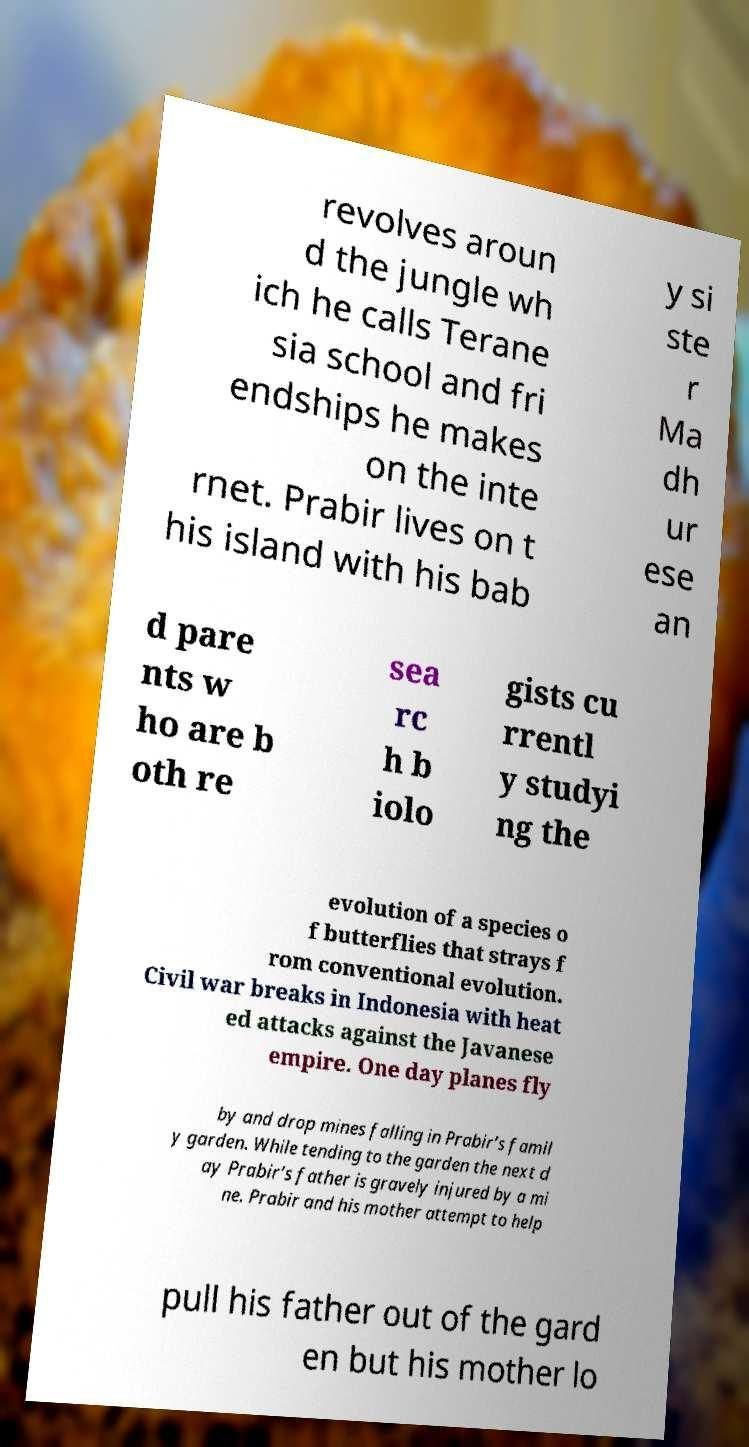For documentation purposes, I need the text within this image transcribed. Could you provide that? revolves aroun d the jungle wh ich he calls Terane sia school and fri endships he makes on the inte rnet. Prabir lives on t his island with his bab y si ste r Ma dh ur ese an d pare nts w ho are b oth re sea rc h b iolo gists cu rrentl y studyi ng the evolution of a species o f butterflies that strays f rom conventional evolution. Civil war breaks in Indonesia with heat ed attacks against the Javanese empire. One day planes fly by and drop mines falling in Prabir’s famil y garden. While tending to the garden the next d ay Prabir’s father is gravely injured by a mi ne. Prabir and his mother attempt to help pull his father out of the gard en but his mother lo 